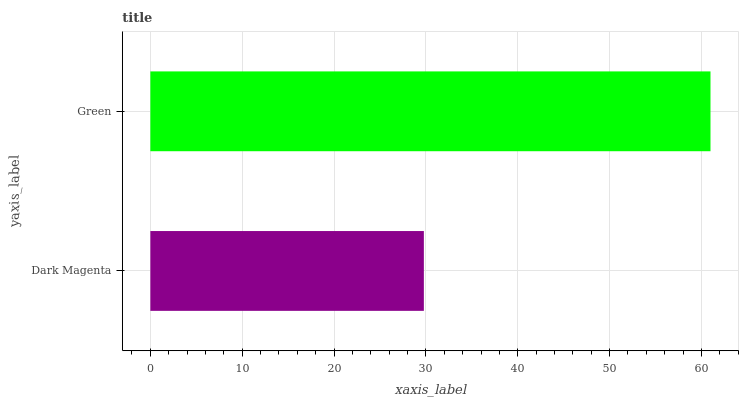Is Dark Magenta the minimum?
Answer yes or no. Yes. Is Green the maximum?
Answer yes or no. Yes. Is Green the minimum?
Answer yes or no. No. Is Green greater than Dark Magenta?
Answer yes or no. Yes. Is Dark Magenta less than Green?
Answer yes or no. Yes. Is Dark Magenta greater than Green?
Answer yes or no. No. Is Green less than Dark Magenta?
Answer yes or no. No. Is Green the high median?
Answer yes or no. Yes. Is Dark Magenta the low median?
Answer yes or no. Yes. Is Dark Magenta the high median?
Answer yes or no. No. Is Green the low median?
Answer yes or no. No. 